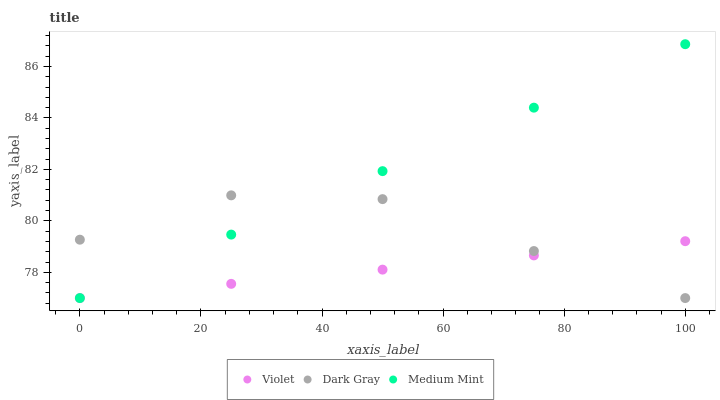Does Violet have the minimum area under the curve?
Answer yes or no. Yes. Does Medium Mint have the maximum area under the curve?
Answer yes or no. Yes. Does Medium Mint have the minimum area under the curve?
Answer yes or no. No. Does Violet have the maximum area under the curve?
Answer yes or no. No. Is Violet the smoothest?
Answer yes or no. Yes. Is Dark Gray the roughest?
Answer yes or no. Yes. Is Medium Mint the smoothest?
Answer yes or no. No. Is Medium Mint the roughest?
Answer yes or no. No. Does Dark Gray have the lowest value?
Answer yes or no. Yes. Does Medium Mint have the highest value?
Answer yes or no. Yes. Does Violet have the highest value?
Answer yes or no. No. Does Medium Mint intersect Dark Gray?
Answer yes or no. Yes. Is Medium Mint less than Dark Gray?
Answer yes or no. No. Is Medium Mint greater than Dark Gray?
Answer yes or no. No. 